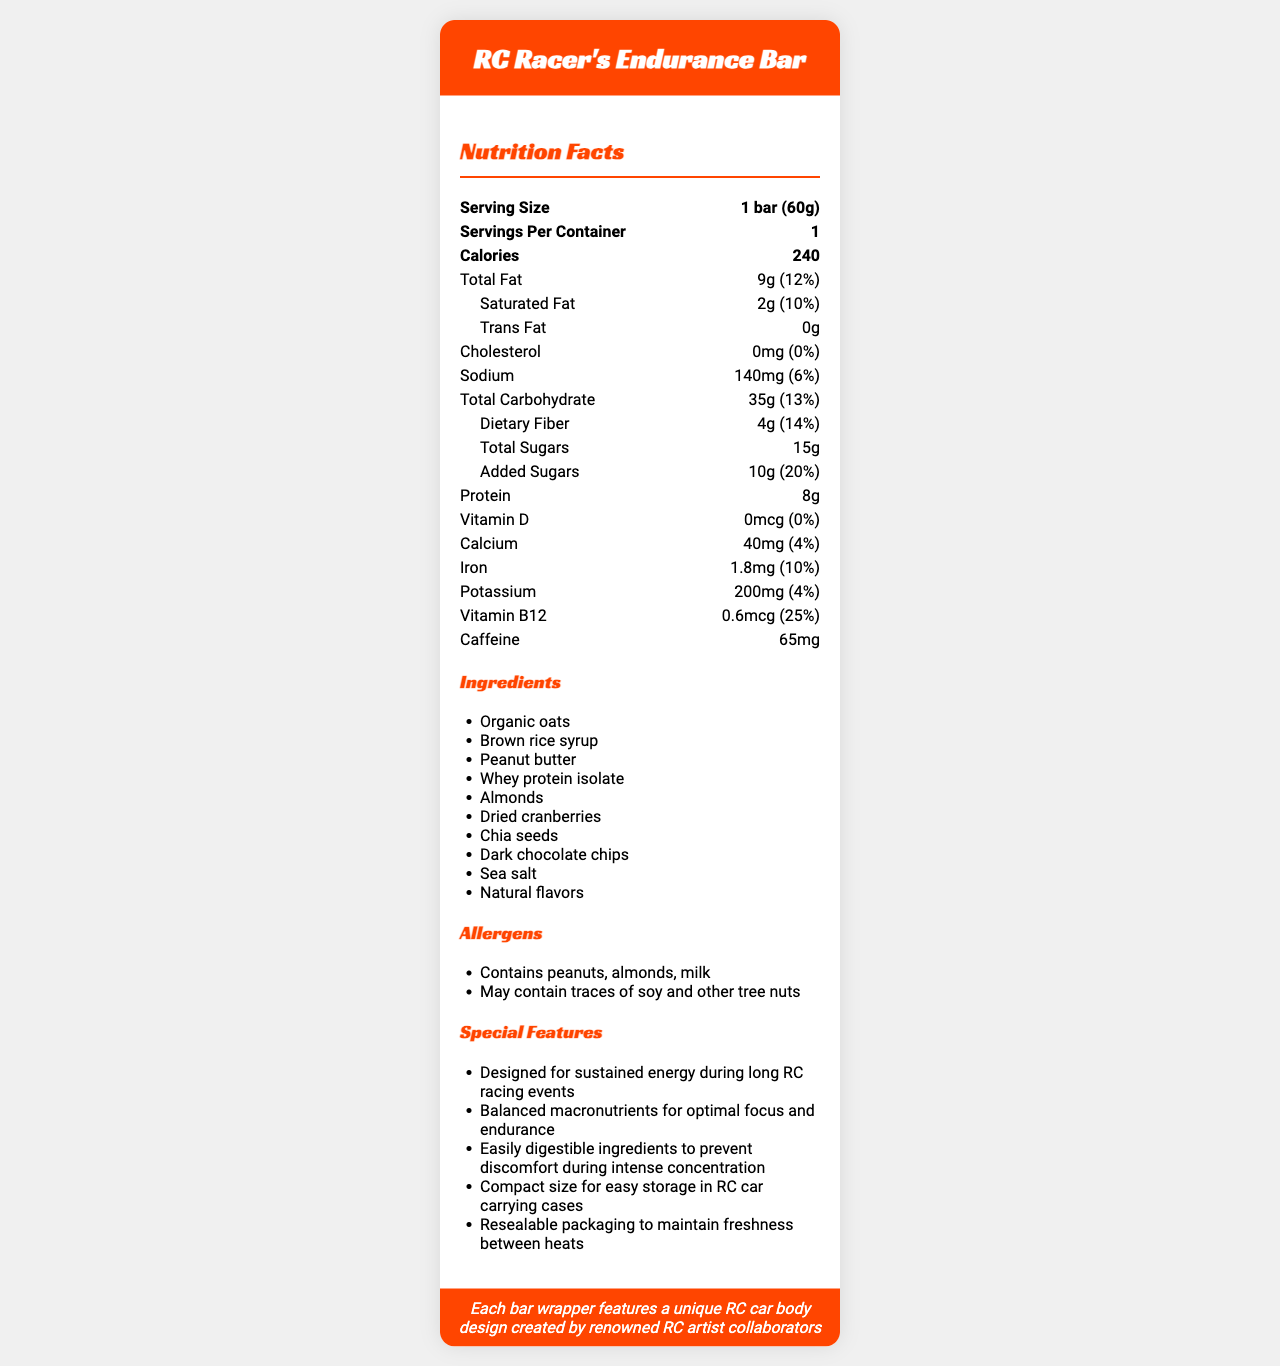What is the serving size of the RC Racer's Endurance Bar? The serving size is directly listed in the nutrition facts as "1 bar (60g)".
Answer: 1 bar (60g) How many calories are in one serving of the RC Racer's Endurance Bar? The document states that one serving contains 240 calories.
Answer: 240 How much protein does the RC Racer's Endurance Bar contain? The amount of protein in the bar is listed as 8 grams.
Answer: 8g What is the amount of Vitamin B12 provided by the RC Racer's Endurance Bar? The nutrition facts section lists the Vitamin B12 content as 0.6 micrograms.
Answer: 0.6 mcg How much fiber is in the RC Racer's Endurance Bar? The nutrition facts state that there are 4 grams of dietary fiber in the bar.
Answer: 4g What percentage of the daily value of calcium does the RC Racer's Endurance Bar provide? The document lists calcium as 40mg, which corresponds to 4% of the daily value.
Answer: 4% Is there cholesterol in the RC Racer's Endurance Bar? The nutrition facts indicate that the bar contains 0mg of cholesterol, which is 0% of the daily value.
Answer: No Does this energy bar contain caffeine? The document shows that the bar contains 65mg of caffeine.
Answer: Yes What are the main ingredients of the RC Racer's Endurance Bar? The ingredients section lists the primary ingredients first.
Answer: Organic oats, Brown rice syrup, Peanut butter Which of the following allergens are contained in the RC Racer's Endurance Bar? A. Peanut B. Almonds C. Milk D. All of the above The allergens listed include peanuts, almonds, and milk, making "All of the above" the correct answer.
Answer: D What special feature makes this energy bar suitable for RC car enthusiasts during long racing events? The special features list mentions that the bar is designed for sustained energy during long RC racing events.
Answer: Designed for sustained energy during long RC racing events What is the total amount of sugars in the RC Racer's Endurance Bar? A. 10g B. 15g C. 25g The total sugars amount is listed as 15g.
Answer: B Does the RC Racer's Endurance Bar contain trans fat? The nutrition facts table explicitly states that the bar contains 0g of trans fat.
Answer: No Can you tell if the RC Racer's Endurance Bar is gluten-free? The document does not specify whether the bar is gluten-free or not.
Answer: Not enough information Describe the main purpose and features of the RC Racer's Endurance Bar. The document provides detailed information on the nutritional content, ingredients, special features, and allergens of the energy bar, emphasizing its design for RC car racers.
Answer: The RC Racer's Endurance Bar is designed to provide sustained energy and balanced macronutrients for optimal focus and endurance during long RC racing events. It includes ingredients like organic oats, brown rice syrup, and peanut butter. Notable features include easily digestible ingredients to prevent discomfort, compact size, resealable packaging, and a unique RC car body design on each wrapper. 